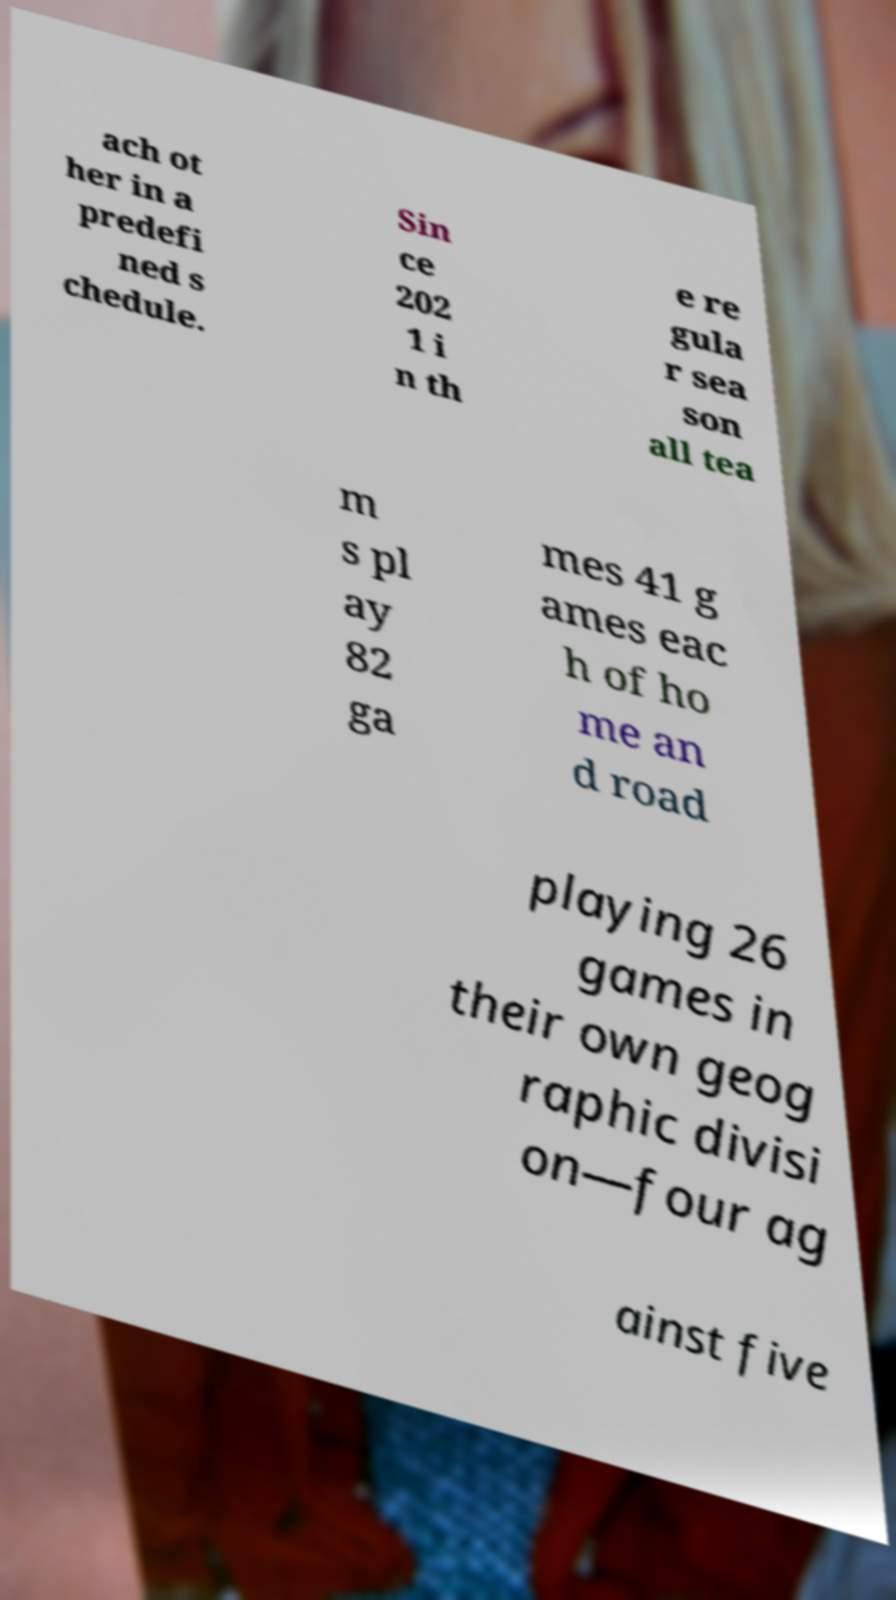For documentation purposes, I need the text within this image transcribed. Could you provide that? ach ot her in a predefi ned s chedule. Sin ce 202 1 i n th e re gula r sea son all tea m s pl ay 82 ga mes 41 g ames eac h of ho me an d road playing 26 games in their own geog raphic divisi on—four ag ainst five 